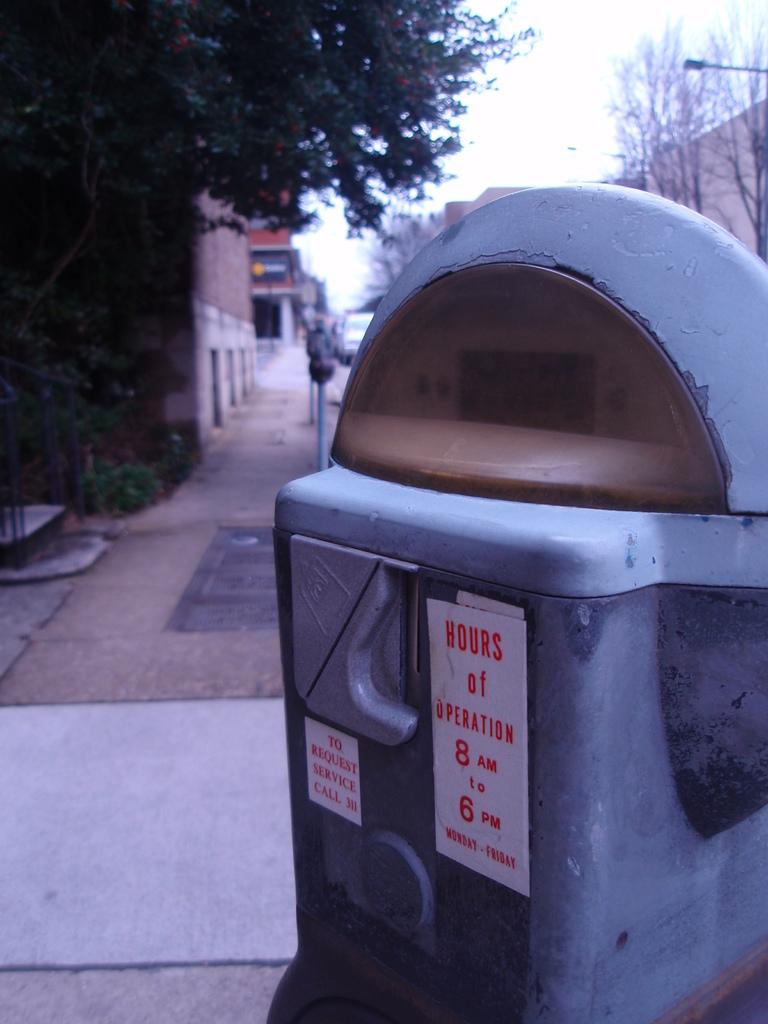What are the hours of operation?
Your response must be concise. 8am to 6pm. How to request service?
Provide a short and direct response. Call 311. 